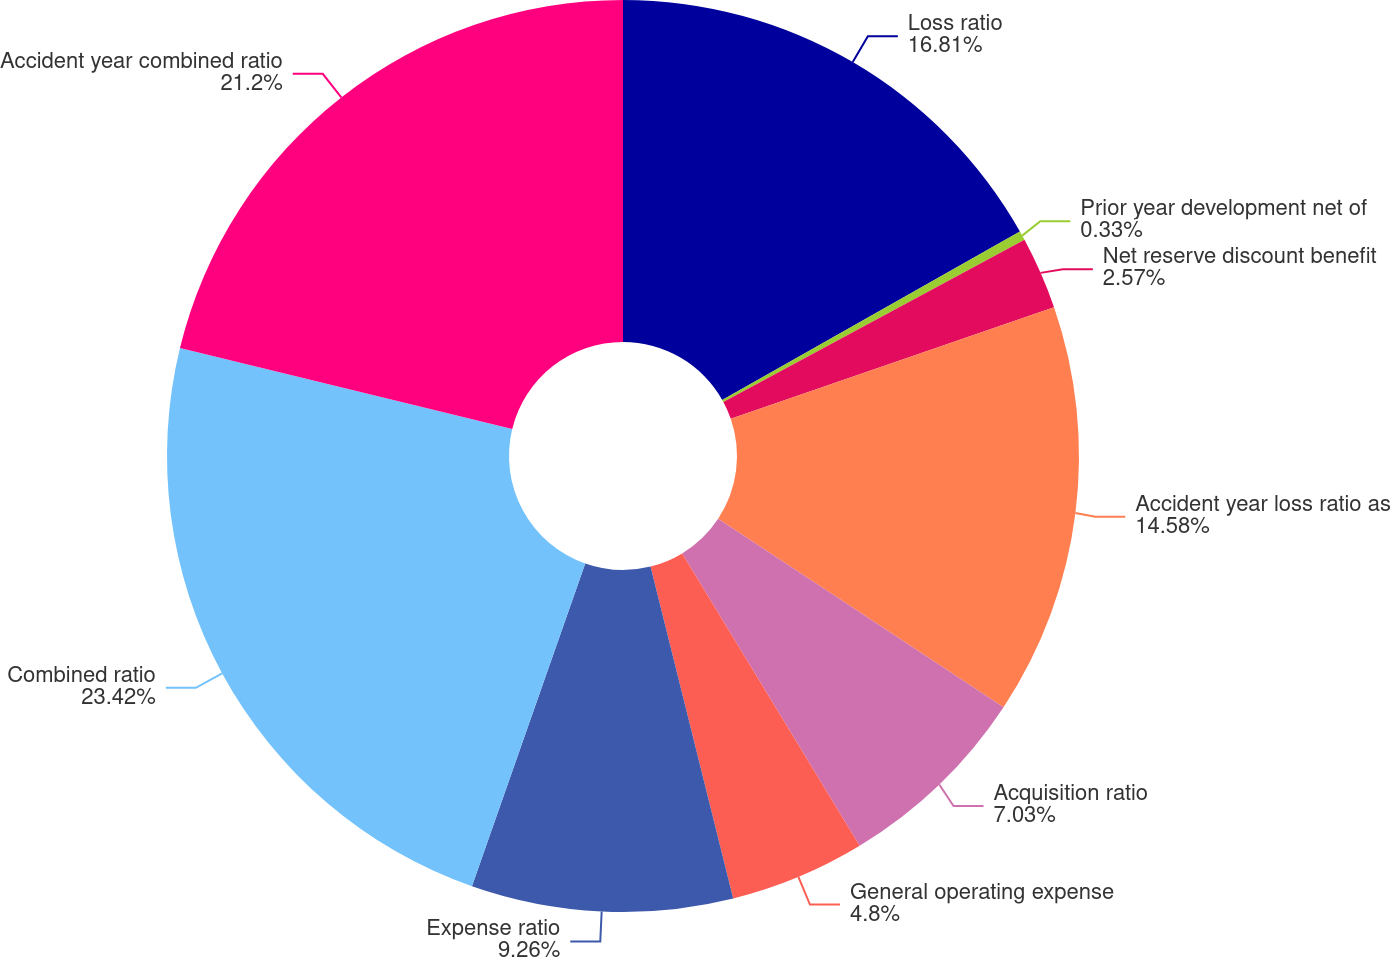<chart> <loc_0><loc_0><loc_500><loc_500><pie_chart><fcel>Loss ratio<fcel>Prior year development net of<fcel>Net reserve discount benefit<fcel>Accident year loss ratio as<fcel>Acquisition ratio<fcel>General operating expense<fcel>Expense ratio<fcel>Combined ratio<fcel>Accident year combined ratio<nl><fcel>16.81%<fcel>0.33%<fcel>2.57%<fcel>14.58%<fcel>7.03%<fcel>4.8%<fcel>9.26%<fcel>23.43%<fcel>21.2%<nl></chart> 